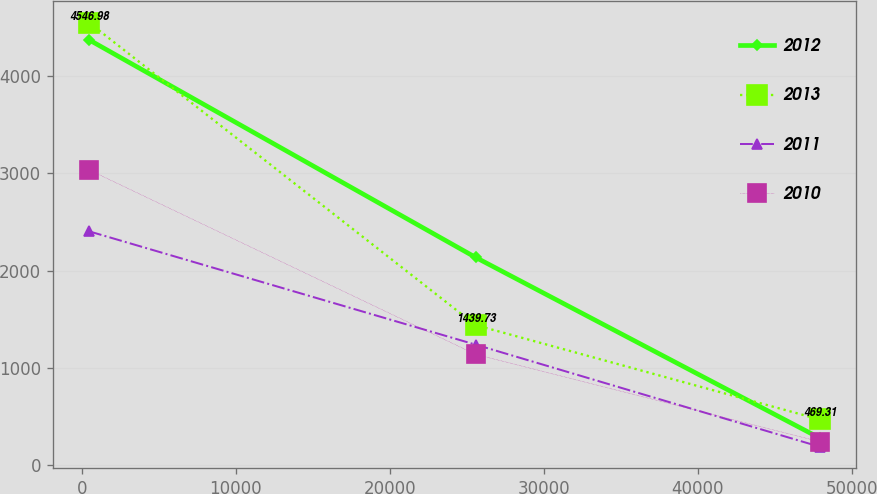Convert chart. <chart><loc_0><loc_0><loc_500><loc_500><line_chart><ecel><fcel>2012<fcel>2013<fcel>2011<fcel>2010<nl><fcel>468.62<fcel>4370.44<fcel>4546.98<fcel>2402.65<fcel>3034.11<nl><fcel>25572.1<fcel>2135.37<fcel>1439.73<fcel>1238.54<fcel>1138.95<nl><fcel>47929.6<fcel>278.57<fcel>469.31<fcel>189.19<fcel>241.15<nl></chart> 